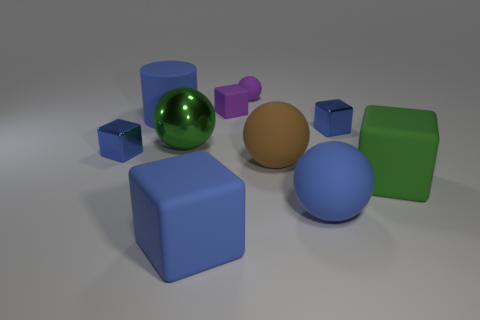Are there fewer purple matte blocks than tiny blue cubes?
Provide a short and direct response. Yes. Is there anything else that has the same size as the green rubber thing?
Keep it short and to the point. Yes. Is the small matte sphere the same color as the big metal ball?
Provide a short and direct response. No. Is the number of large brown spheres greater than the number of big green rubber cylinders?
Provide a succinct answer. Yes. How many other objects are there of the same color as the matte cylinder?
Offer a terse response. 4. How many spheres are behind the large blue ball to the left of the big green block?
Make the answer very short. 3. There is a small purple sphere; are there any purple rubber objects to the left of it?
Your response must be concise. Yes. What is the shape of the small blue metal object on the right side of the rubber cube behind the large blue cylinder?
Provide a short and direct response. Cube. Is the number of cubes that are behind the big blue matte cube less than the number of blue metal blocks right of the large metal ball?
Keep it short and to the point. No. There is a small rubber thing that is the same shape as the large green shiny object; what is its color?
Ensure brevity in your answer.  Purple. 